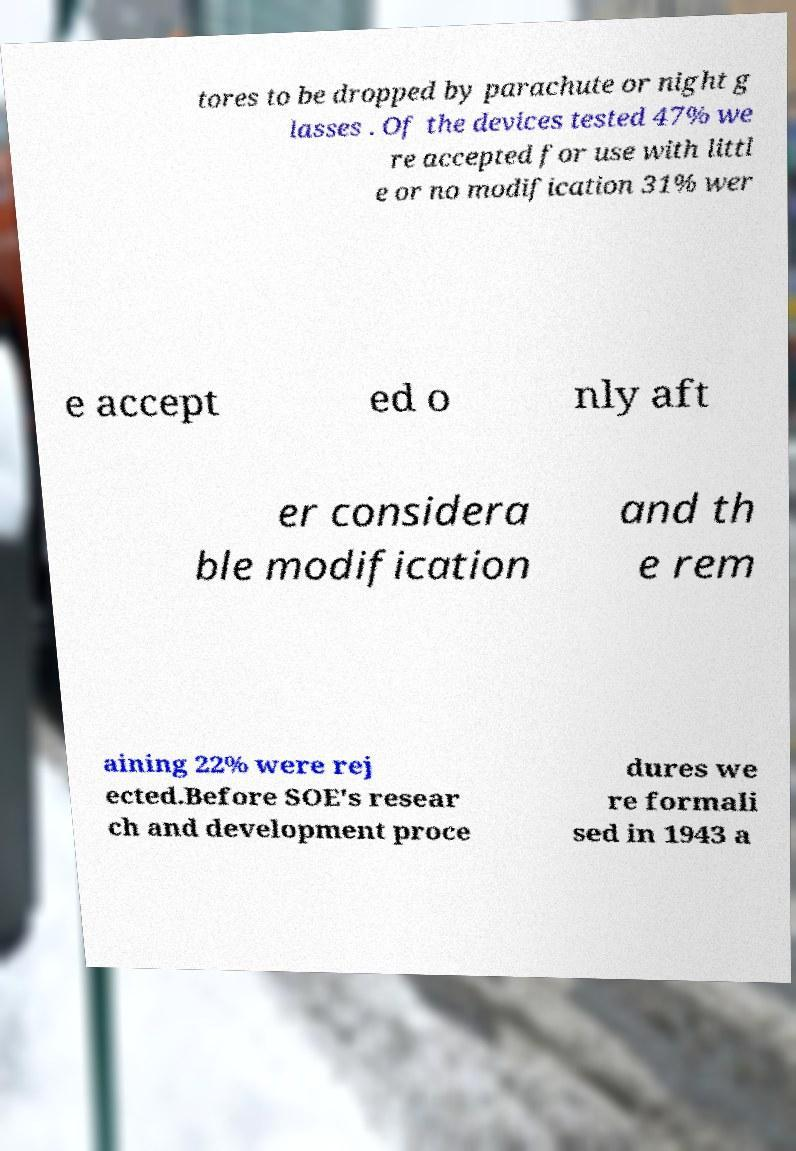For documentation purposes, I need the text within this image transcribed. Could you provide that? tores to be dropped by parachute or night g lasses . Of the devices tested 47% we re accepted for use with littl e or no modification 31% wer e accept ed o nly aft er considera ble modification and th e rem aining 22% were rej ected.Before SOE's resear ch and development proce dures we re formali sed in 1943 a 